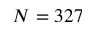<formula> <loc_0><loc_0><loc_500><loc_500>N = 3 2 7</formula> 